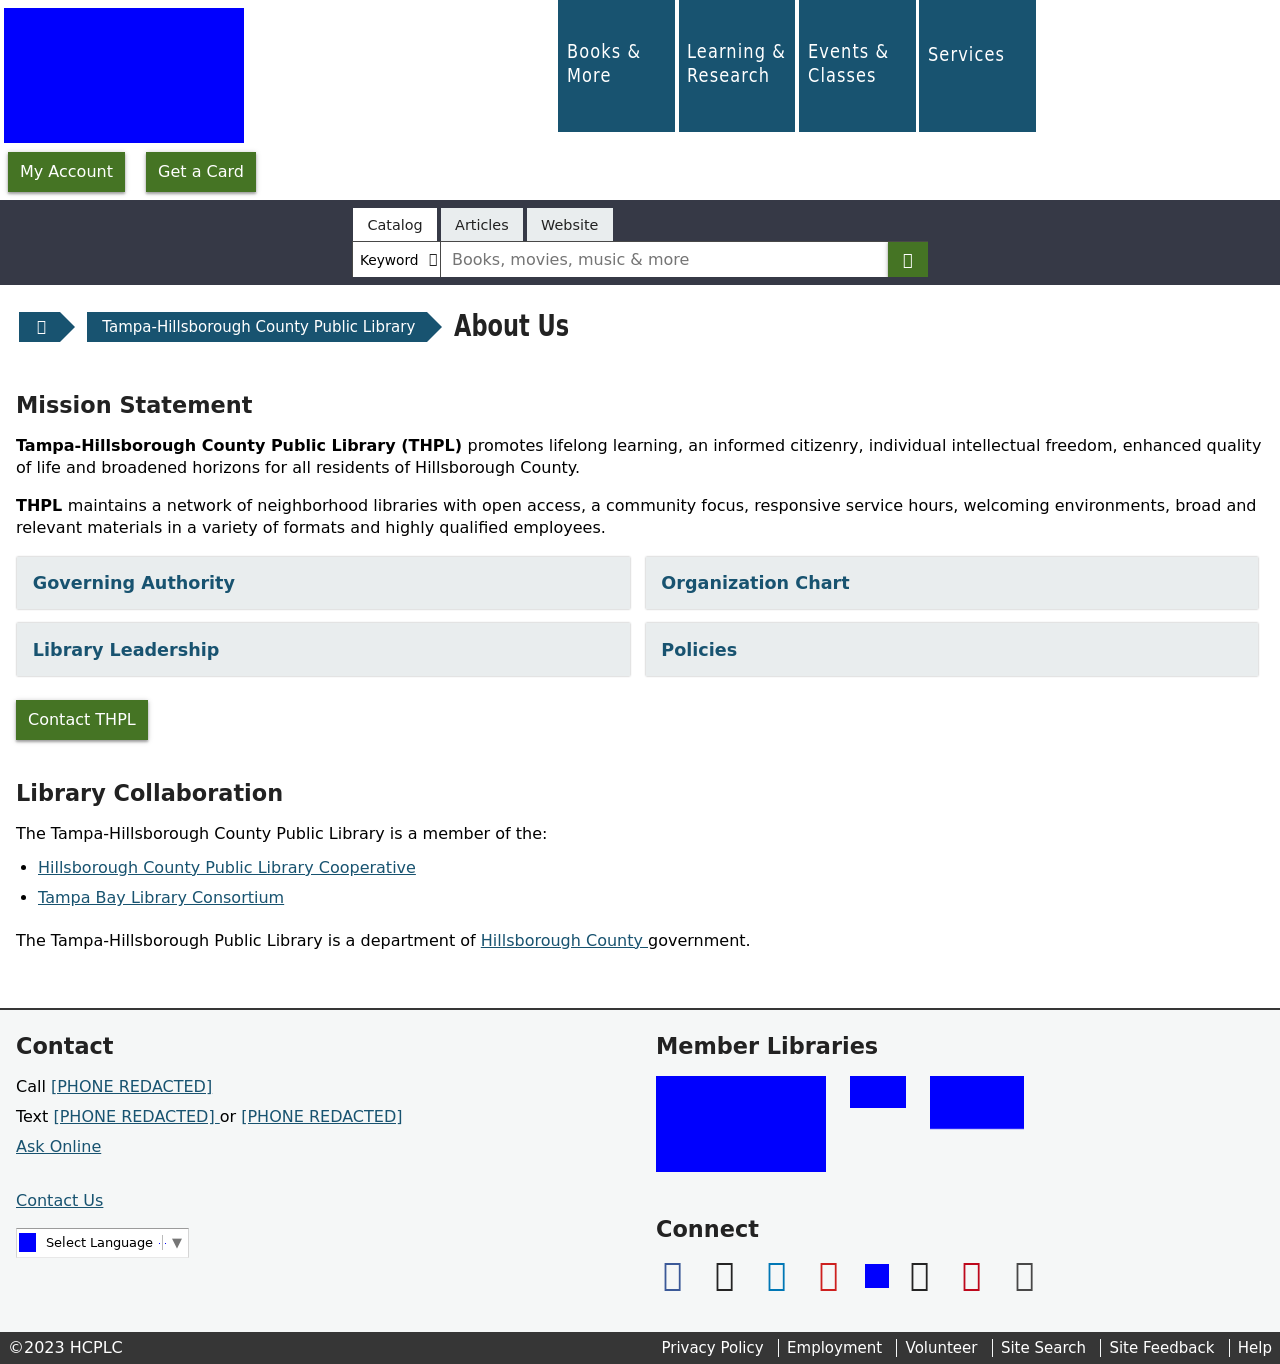Can you tell me more about the Library Leadership links shown on the website? The 'Library Leadership' link likely directs users to a page detailing the administrative structure of the library, including profiles and roles of key library leaders such as directors, managers, and department heads. This section helps patrons and stakeholders understand the hierarchy and governance of the library, encouraging transparency and interaction with the library's leadership.  Are there reasons why the library would emphasize its collaboration with other libraries or consortiums? Emphasizing collaboration with other libraries or consortiums demonstrates the library’s commitment to resource sharing, professional development, and broadening service offerings. Partnerships like these can enhance the library's ability to offer access to a wider range of materials, share costs for expensive resources, and provide more comprehensive services to the community. 